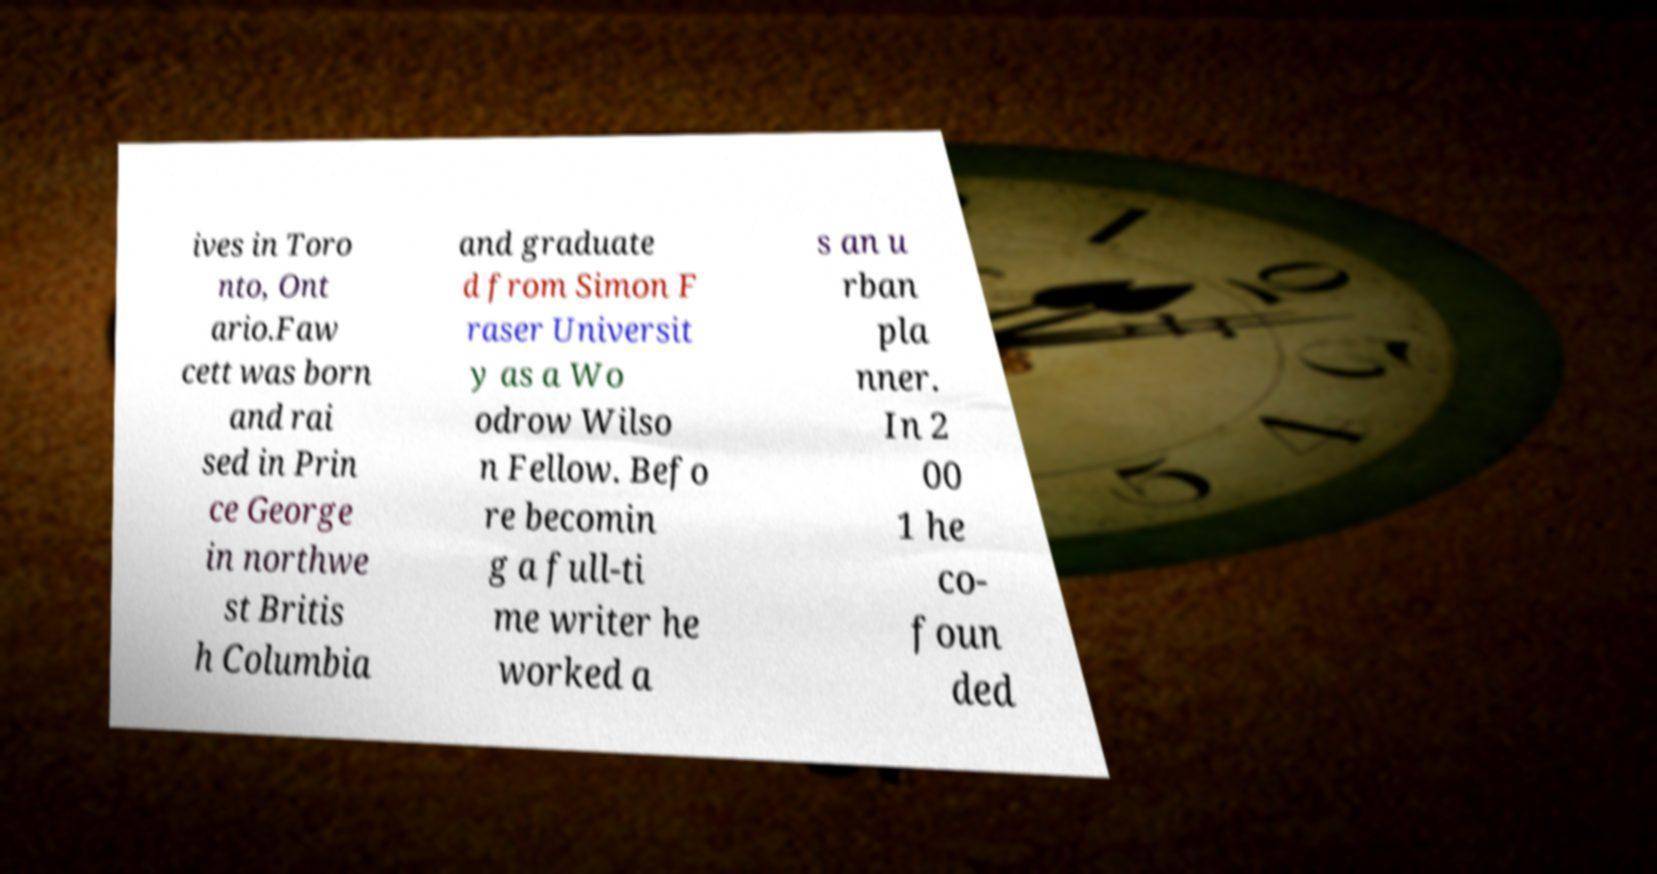Please read and relay the text visible in this image. What does it say? ives in Toro nto, Ont ario.Faw cett was born and rai sed in Prin ce George in northwe st Britis h Columbia and graduate d from Simon F raser Universit y as a Wo odrow Wilso n Fellow. Befo re becomin g a full-ti me writer he worked a s an u rban pla nner. In 2 00 1 he co- foun ded 